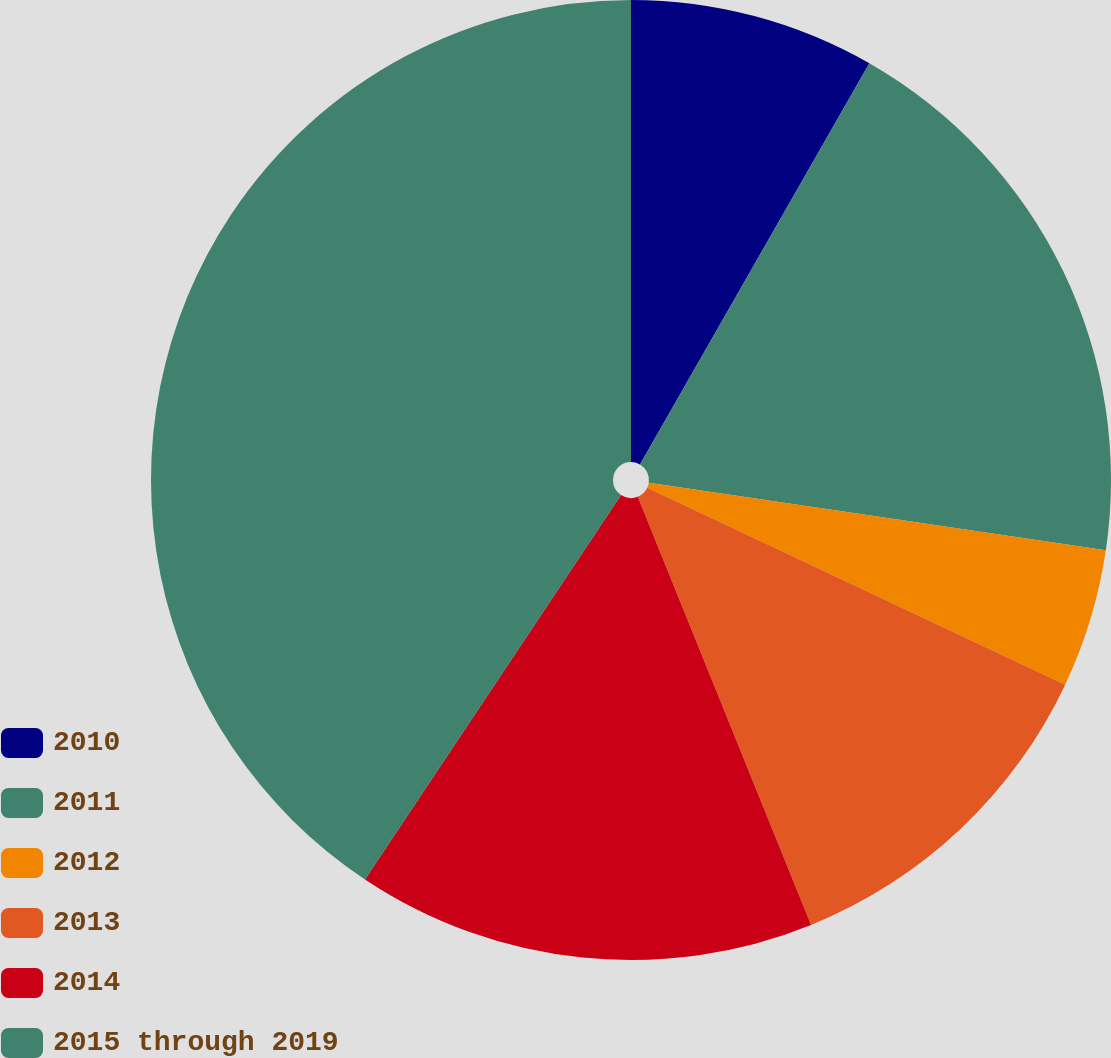Convert chart. <chart><loc_0><loc_0><loc_500><loc_500><pie_chart><fcel>2010<fcel>2011<fcel>2012<fcel>2013<fcel>2014<fcel>2015 through 2019<nl><fcel>8.27%<fcel>19.07%<fcel>4.67%<fcel>11.87%<fcel>15.47%<fcel>40.65%<nl></chart> 